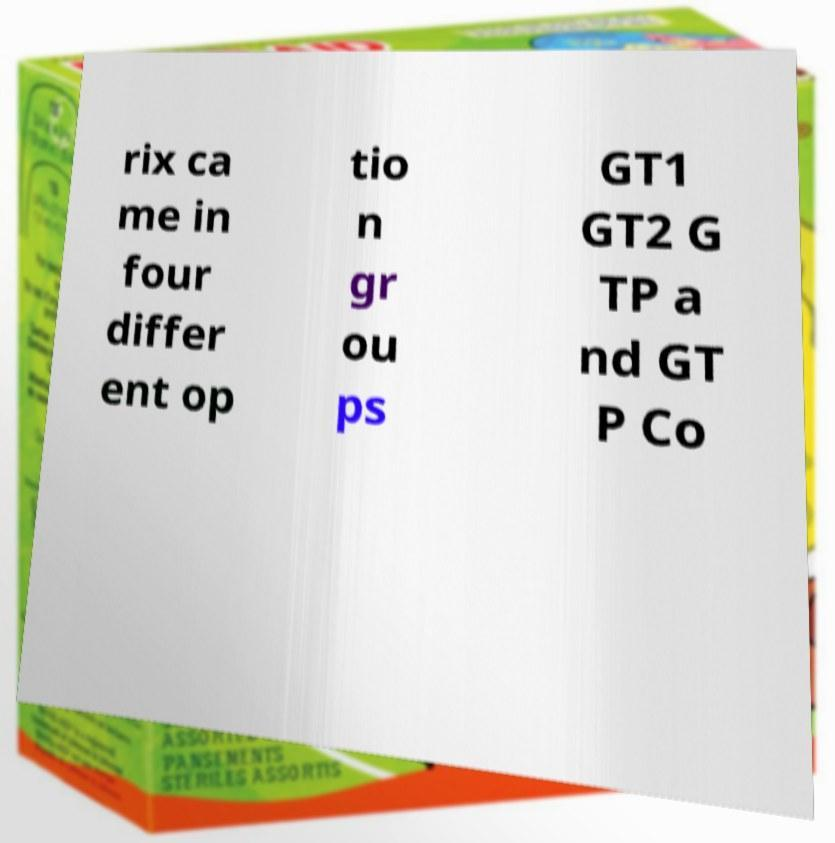What messages or text are displayed in this image? I need them in a readable, typed format. rix ca me in four differ ent op tio n gr ou ps GT1 GT2 G TP a nd GT P Co 